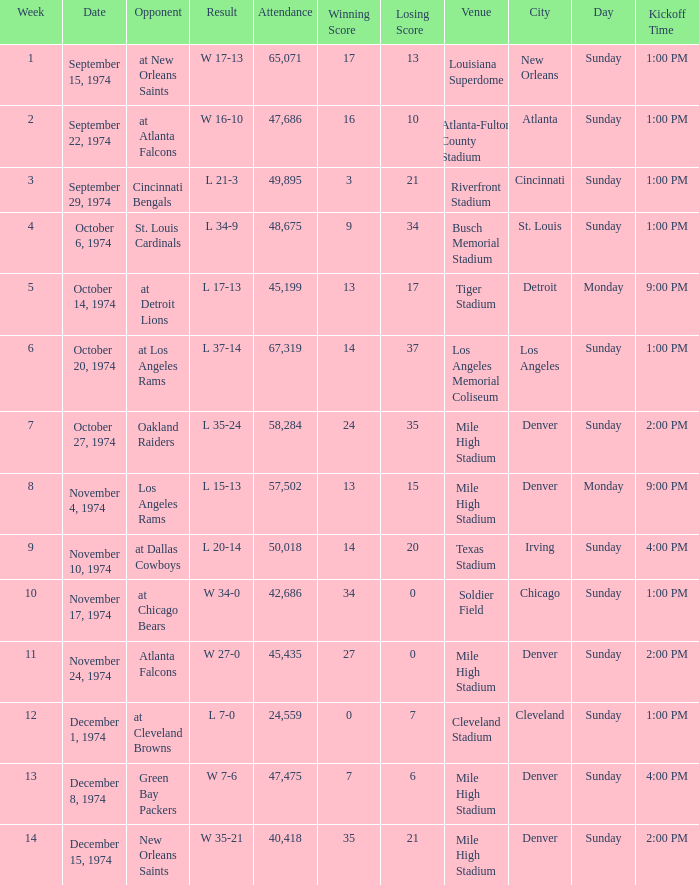Which week was the game played on December 8, 1974? 13.0. 